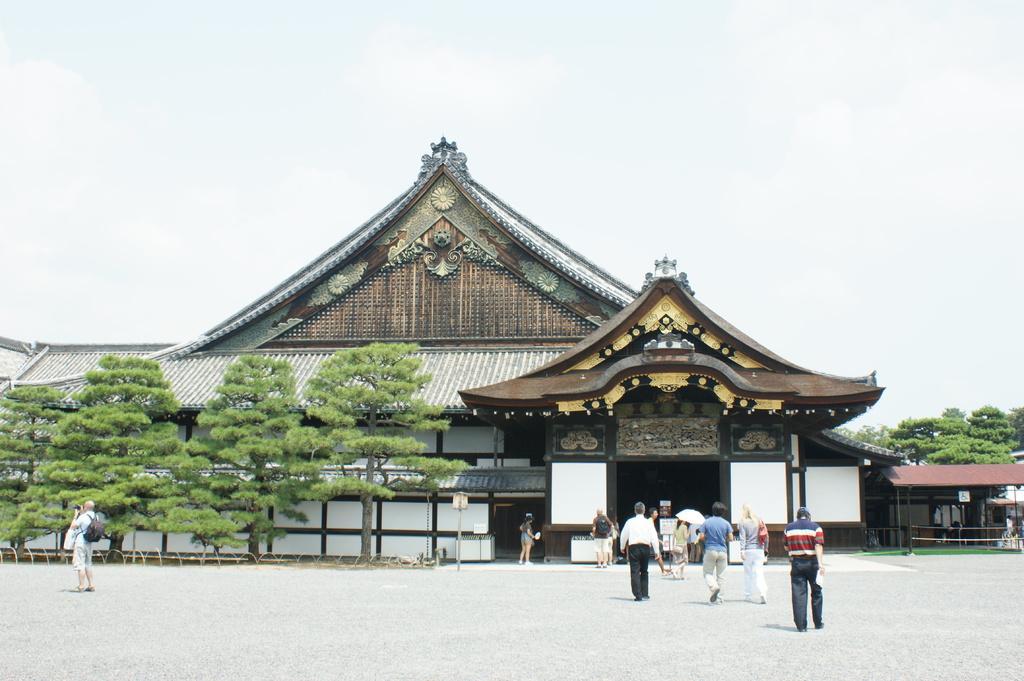How would you summarize this image in a sentence or two? In this picture there are people and we can see ground, boards, pole, shed, house, grass and trees. In the background of the image we can see the sky. 